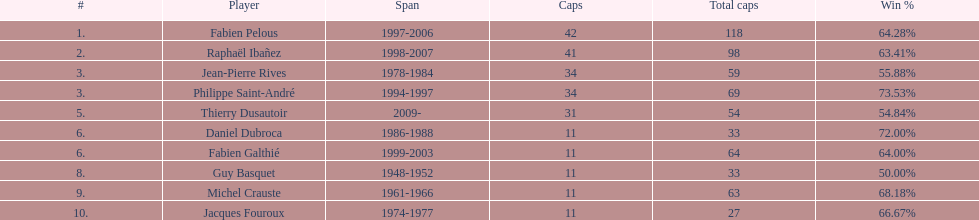Which player has the highest win percentage? Philippe Saint-André. 